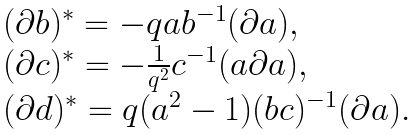<formula> <loc_0><loc_0><loc_500><loc_500>\begin{array} { l } { { ( \partial b ) ^ { * } = - q a b ^ { - 1 } ( \partial a ) , } } \\ { { ( \partial c ) ^ { * } = - \frac { 1 } { q ^ { 2 } } c ^ { - 1 } ( a \partial a ) , } } \\ { { ( \partial d ) ^ { * } = q ( a ^ { 2 } - 1 ) ( b c ) ^ { - 1 } ( \partial a ) . } } \end{array}</formula> 